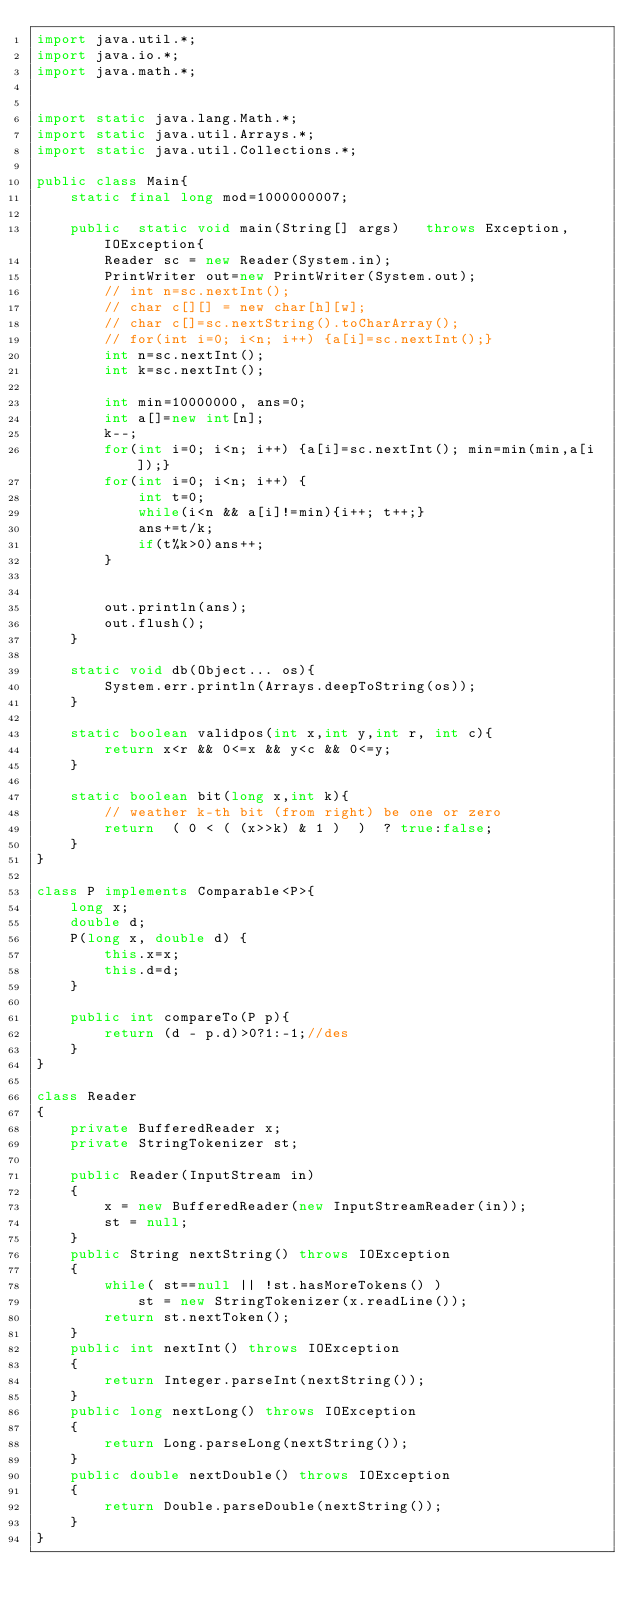Convert code to text. <code><loc_0><loc_0><loc_500><loc_500><_Java_>import java.util.*;
import java.io.*;
import java.math.*;
 
 
import static java.lang.Math.*;
import static java.util.Arrays.*;
import static java.util.Collections.*;
 
public class Main{
    static final long mod=1000000007;
    
    public  static void main(String[] args)   throws Exception, IOException{
        Reader sc = new Reader(System.in);
        PrintWriter out=new PrintWriter(System.out);
        // int n=sc.nextInt();
        // char c[][] = new char[h][w];
        // char c[]=sc.nextString().toCharArray();
        // for(int i=0; i<n; i++) {a[i]=sc.nextInt();}
        int n=sc.nextInt();
        int k=sc.nextInt();

        int min=10000000, ans=0;
        int a[]=new int[n];
        k--;
        for(int i=0; i<n; i++) {a[i]=sc.nextInt(); min=min(min,a[i]);}
        for(int i=0; i<n; i++) {
            int t=0;
            while(i<n && a[i]!=min){i++; t++;}
            ans+=t/k;
            if(t%k>0)ans++;
        }  


        out.println(ans);
        out.flush();
    }

    static void db(Object... os){
        System.err.println(Arrays.deepToString(os));
    }
     
    static boolean validpos(int x,int y,int r, int c){
        return x<r && 0<=x && y<c && 0<=y;
    }
     
    static boolean bit(long x,int k){
        // weather k-th bit (from right) be one or zero
        return  ( 0 < ( (x>>k) & 1 )  )  ? true:false;
    }    
}

class P implements Comparable<P>{
    long x;
    double d;
    P(long x, double d) {
        this.x=x;
        this.d=d;
    } 
      
    public int compareTo(P p){
        return (d - p.d)>0?1:-1;//des
    } 
}

class Reader
{ 
    private BufferedReader x;
    private StringTokenizer st;
    
    public Reader(InputStream in)
    {
        x = new BufferedReader(new InputStreamReader(in));
        st = null;
    }
    public String nextString() throws IOException
    {
        while( st==null || !st.hasMoreTokens() )
            st = new StringTokenizer(x.readLine());
        return st.nextToken();
    }
    public int nextInt() throws IOException
    {
        return Integer.parseInt(nextString());
    }
    public long nextLong() throws IOException
    {
        return Long.parseLong(nextString());
    }
    public double nextDouble() throws IOException
    {
        return Double.parseDouble(nextString());
    }
}</code> 